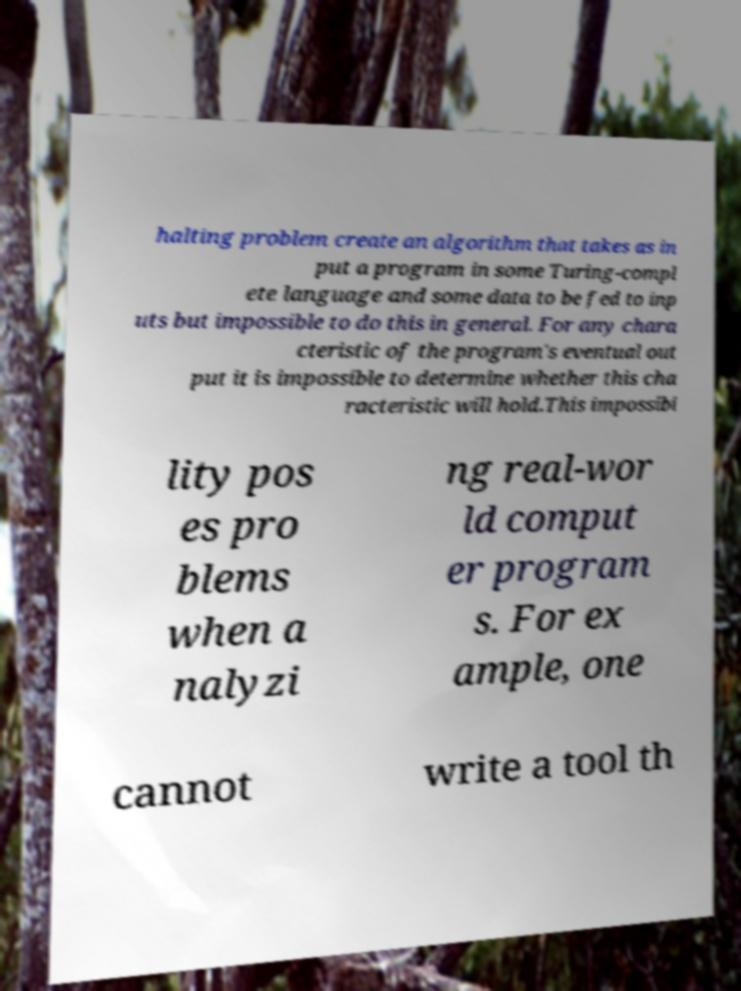Please identify and transcribe the text found in this image. halting problem create an algorithm that takes as in put a program in some Turing-compl ete language and some data to be fed to inp uts but impossible to do this in general. For any chara cteristic of the program's eventual out put it is impossible to determine whether this cha racteristic will hold.This impossibi lity pos es pro blems when a nalyzi ng real-wor ld comput er program s. For ex ample, one cannot write a tool th 